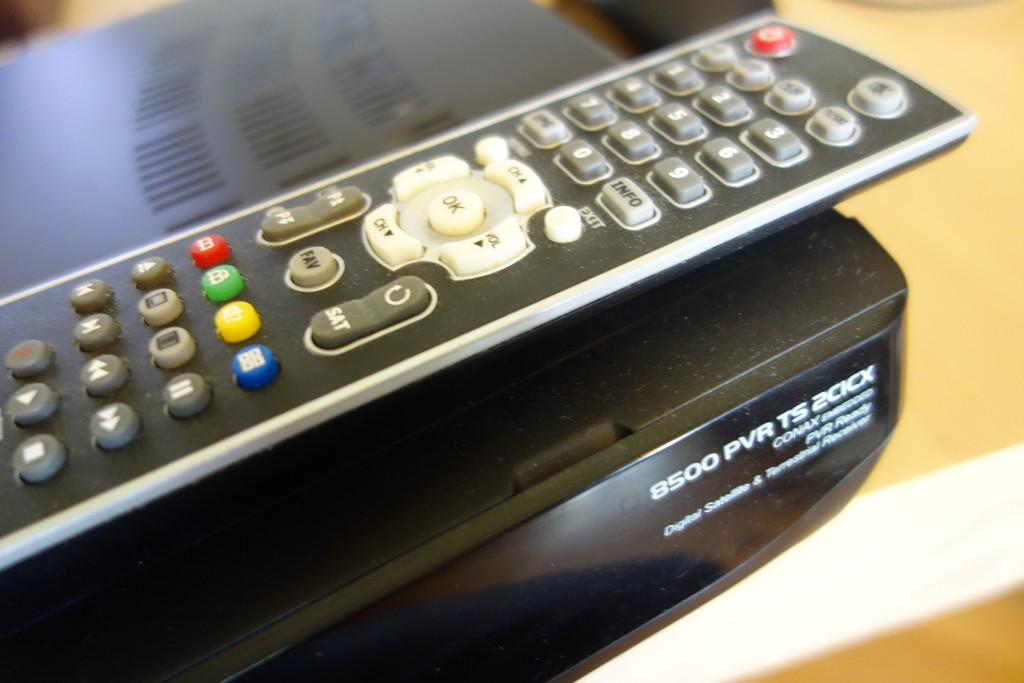<image>
Create a compact narrative representing the image presented. Device modeled 8500 PVR under a remote control. 